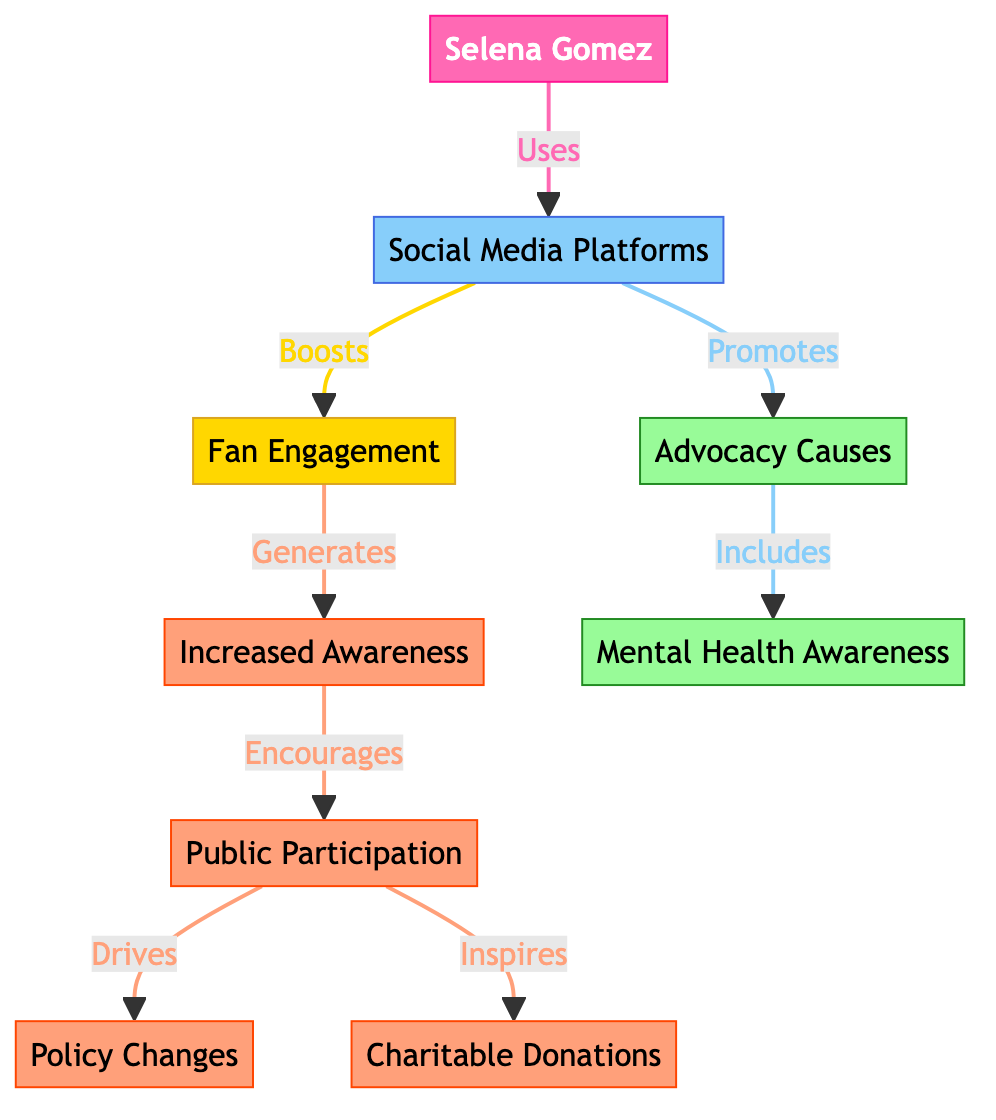What is the central celebrity depicted in the diagram? The diagram highlights Selena Gomez as the central celebrity, indicated by her name prominently displayed in the celebrity node.
Answer: Selena Gomez Which advocacy cause is linked to the celebrity? The diagram shows a direct link from Selena Gomez to the advocacy causes, specifically mentioning mental health as one of the key areas she promotes.
Answer: Mental Health Awareness How many outcomes are listed in the diagram? By counting the nodes related to outcomes, there are four specific outcomes labeled in the diagram: increased awareness, public participation, policy changes, and charitable donations.
Answer: Four What type of social media impact does Selena Gomez have according to the diagram? The diagram illustrates that Selena Gomez uses social media platforms to promote advocacy, highlighting her influence in boosting engagement and raising awareness of important causes.
Answer: Promotes Advocacy What does fan engagement generate according to the flow? The chart illustrates that fan engagement leads to increased awareness, showing a direct flow from engagement to awareness in the advocacy process.
Answer: Increased Awareness Which two outcomes are driven by public participation? Examining the links from public participation in the diagram shows that it inspires both policy changes and charitable donations, indicating its significant impact on these outcomes.
Answer: Policy Changes and Charitable Donations What element directly connects social media platforms to advocacy? The diagram indicates a direct promotional relationship where social media platforms actively promote advocacy causes, showcasing their role in awareness and action.
Answer: Promotes Which advocacy cause is specifically emphasized in the diagram? The diagram specifically emphasizes mental health as an advocacy cause linked to Selena Gomez's initiatives on social media, marking it as a focal point for her activism.
Answer: Mental Health Awareness 